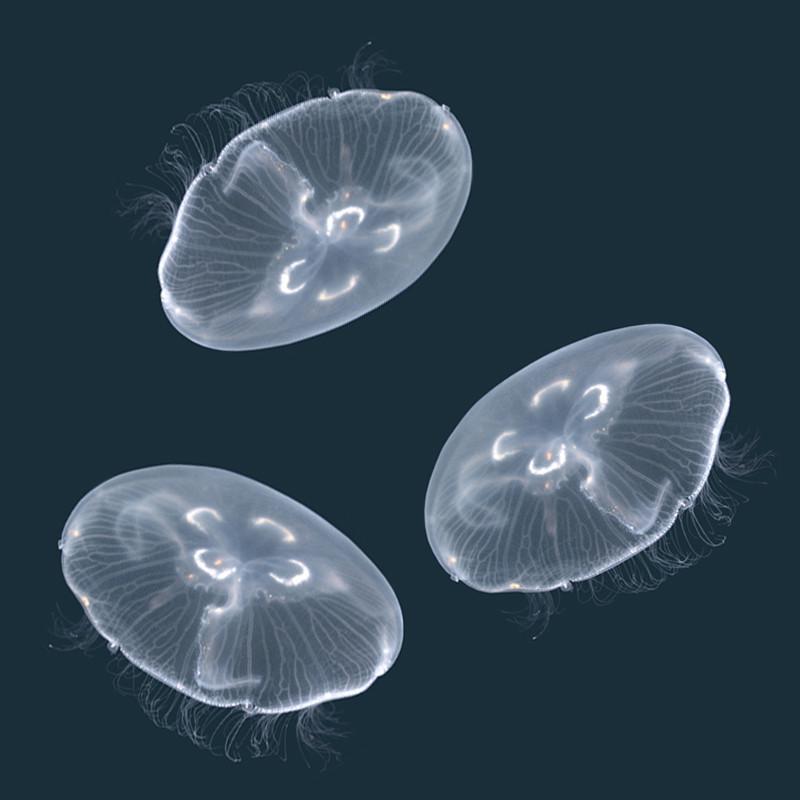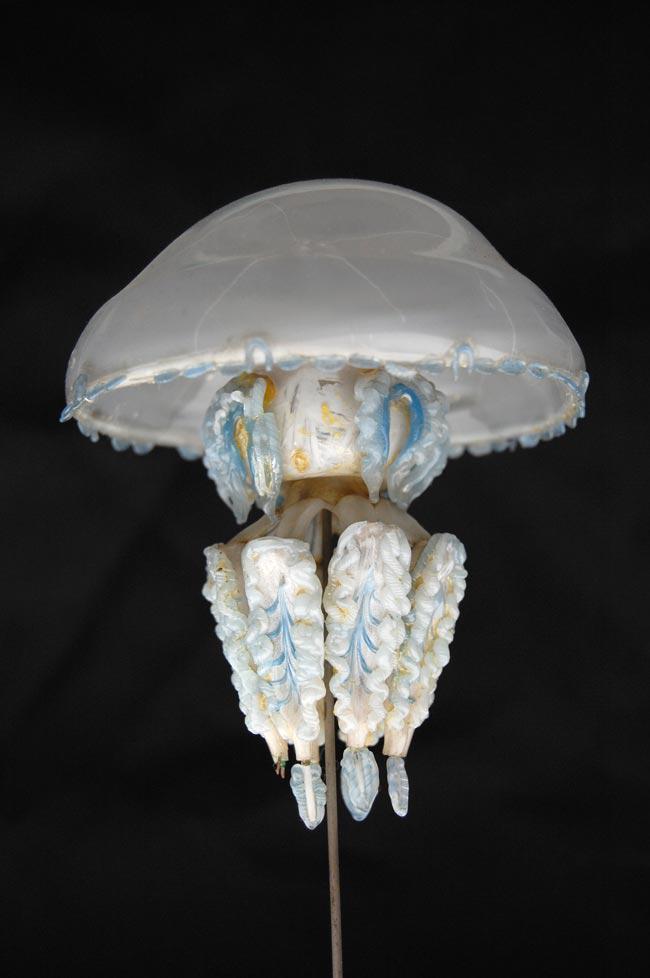The first image is the image on the left, the second image is the image on the right. For the images displayed, is the sentence "The image on the left shows exactly 3 jellyfish." factually correct? Answer yes or no. Yes. The first image is the image on the left, the second image is the image on the right. Considering the images on both sides, is "The left image shows at least two translucent blue jellyfish with short tentacles and mushroom shapes, and the right image includes a jellyfish with aqua coloring and longer tentacles." valid? Answer yes or no. No. 